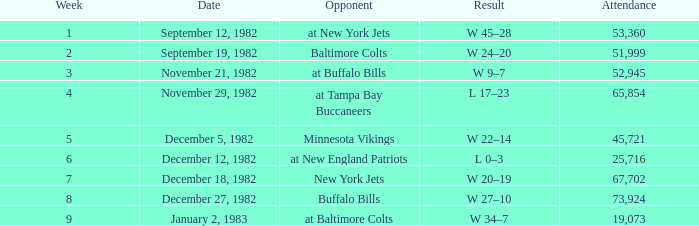What week was the game on September 12, 1982 with an attendance greater than 51,999? 1.0. 